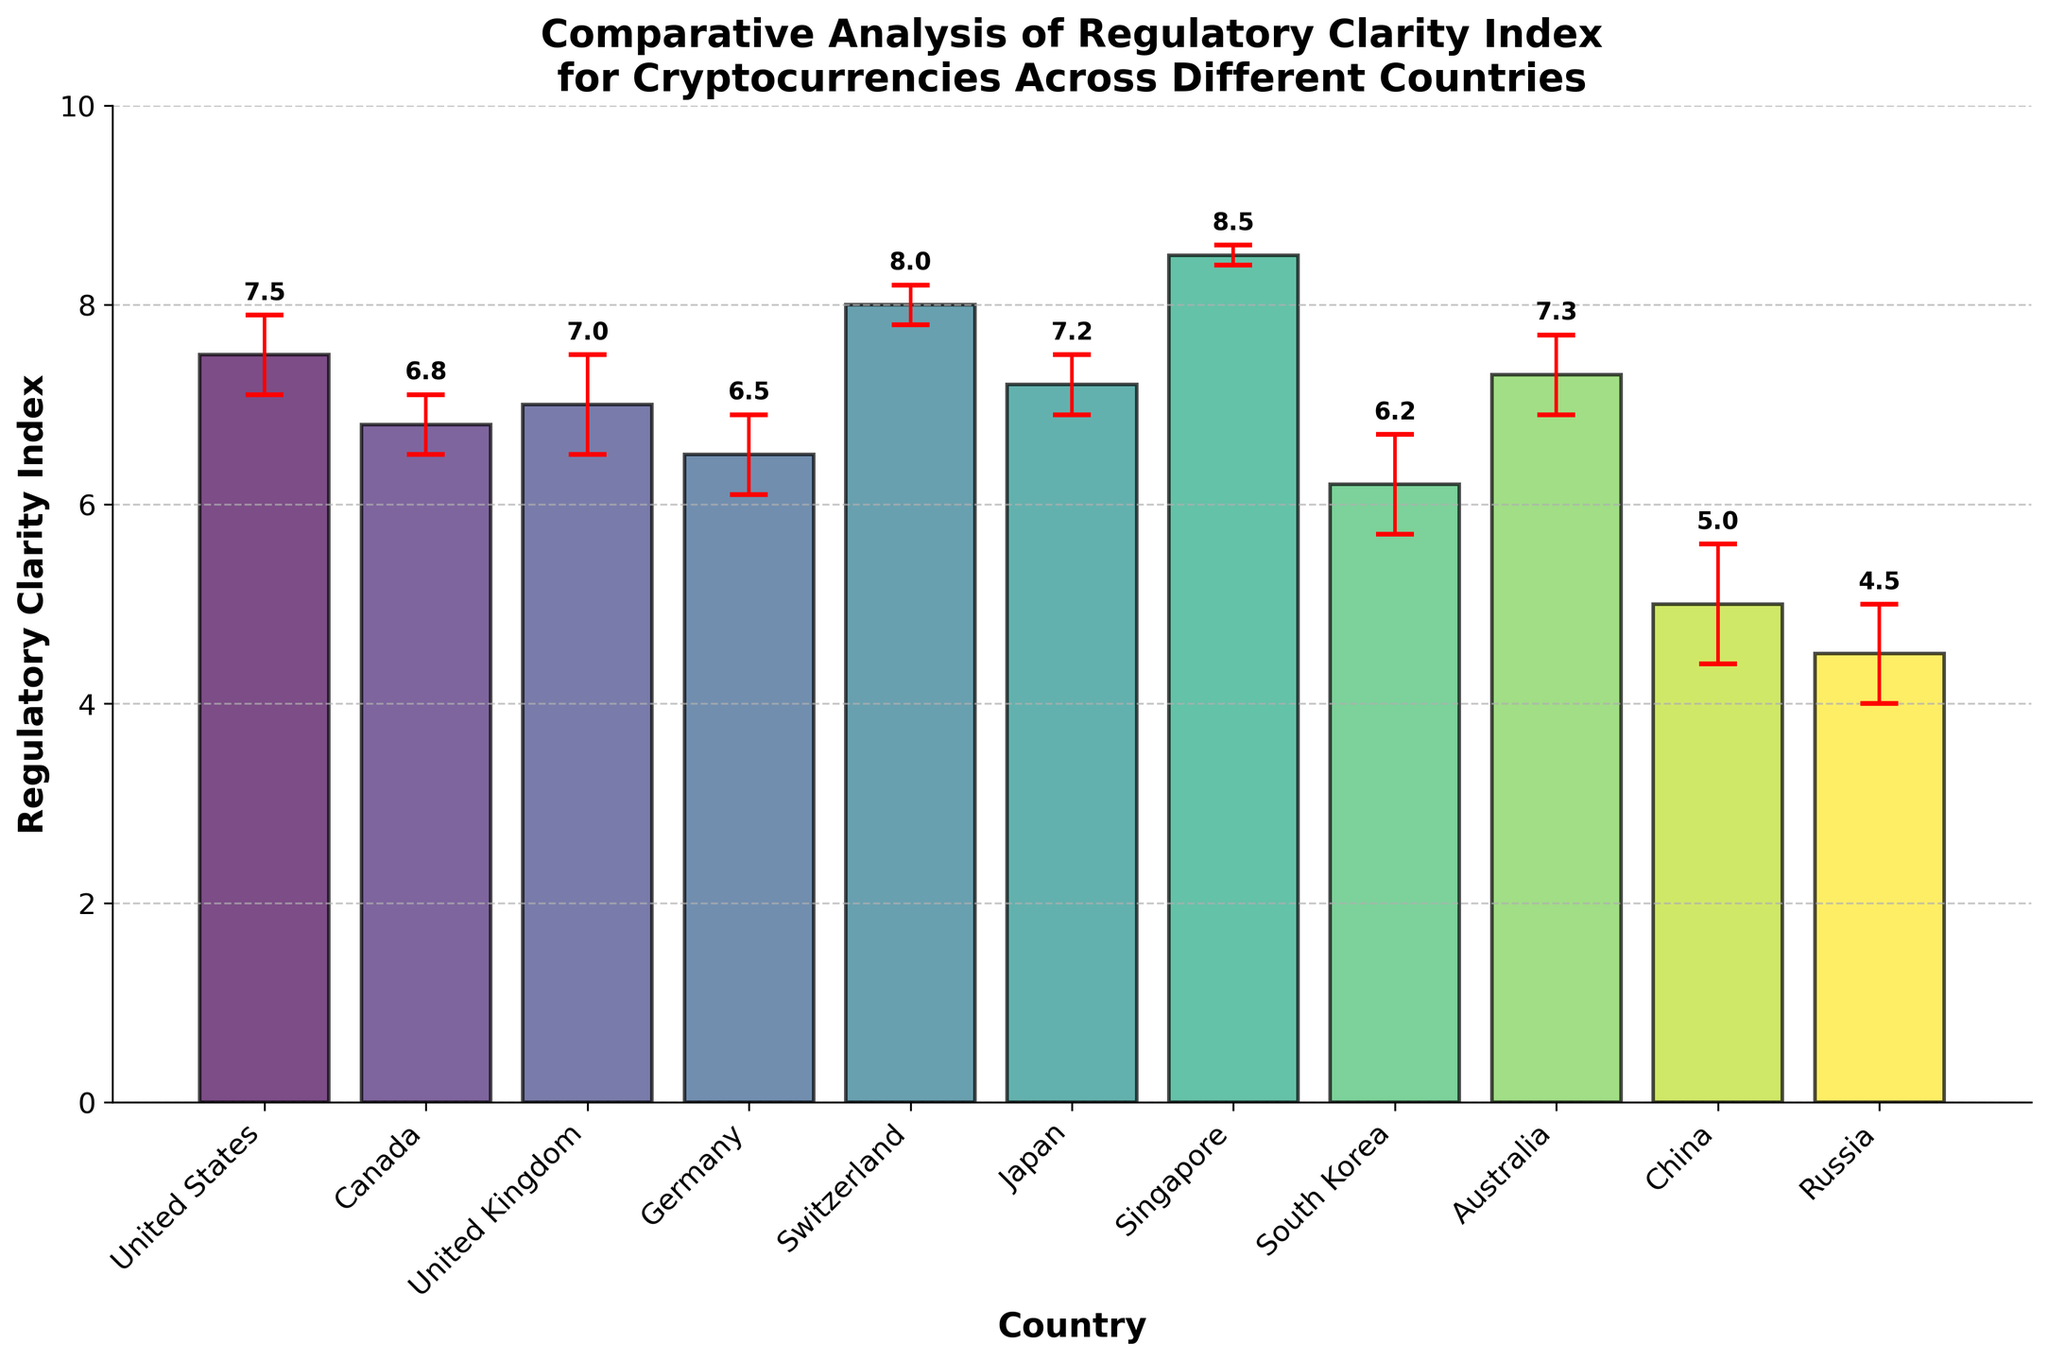What's the title of the plot? The title is displayed at the top of the figure and summarizes what the plot is about.
Answer: Comparative Analysis of Regulatory Clarity Index for Cryptocurrencies Across Different Countries Which country has the highest Regulatory Clarity Index? The highest bar in the plot represents the country with the highest Regulatory Clarity Index.
Answer: Singapore What is the Regulatory Clarity Index for China? Locate the bar corresponding to China and read off the value from the y-axis.
Answer: 5.0 How many countries have a Regulatory Clarity Index higher than 7.0? Count the number of bars whose heights are above the 7.0 mark on the y-axis.
Answer: 5 Which two countries have the closest Regulatory Clarity Index values? Compare the heights of the bars to find the two countries with the closest values.
Answer: United Kingdom and Japan What is the difference in Regulatory Clarity Index between Switzerland and Russia? Subtract the Regulatory Clarity Index of Russia from Switzerland's value.
Answer: 3.5 Which country has the largest standard error, and what is its value? Look for the bar with the longest error bar and read the value from the plot.
Answer: China, 0.6 What is the average Regulatory Clarity Index of all listed countries? Add up all the Regulatory Clarity Index values and divide by the number of countries.
Answer: 6.68 How does the Regulatory Clarity Index of the United States compare to that of Germany? Compare the heights of the bars for the United States and Germany.
Answer: The United States has a higher Regulatory Clarity Index than Germany If the standard error bars were removed, how would it affect the readability of the plot? Without standard error bars, it would be more difficult to ascertain the reliability of the Regulatory Clarity Index values.
Answer: It would reduce the clarity about the uncertainty of the data 